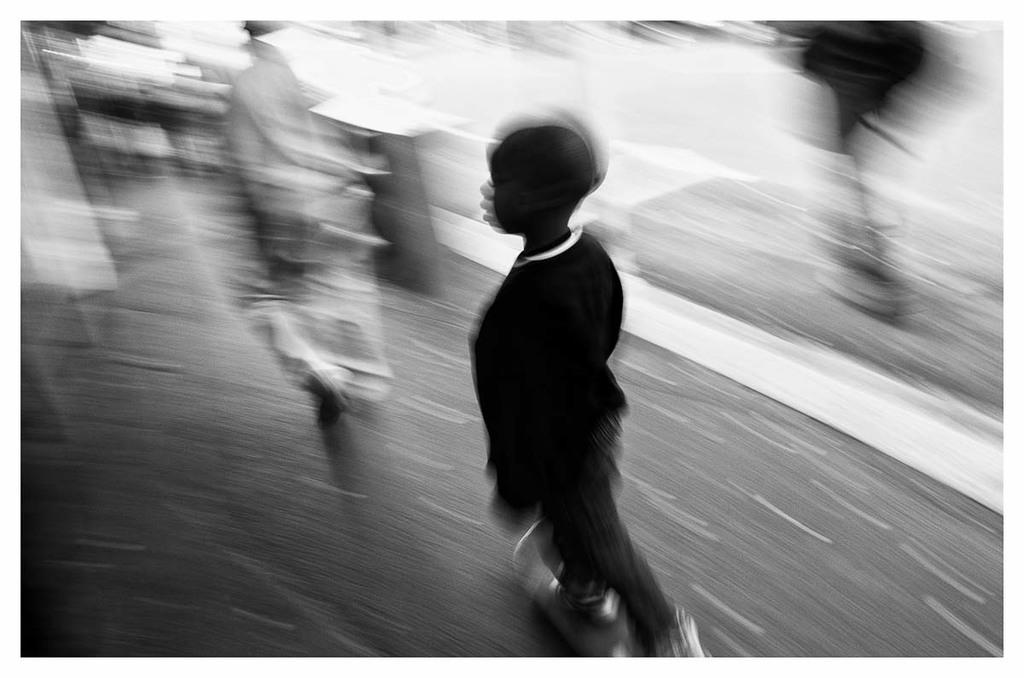What is the main subject of the image? The main subject of the image is a boy. What is the boy doing in the image? The boy is standing in the image. What is the boy standing on? The boy is standing on a surface. Can you describe the background of the image? The background of the image is blurred. What type of stem can be seen growing from the boy's head in the image? There is no stem growing from the boy's head in the image. 